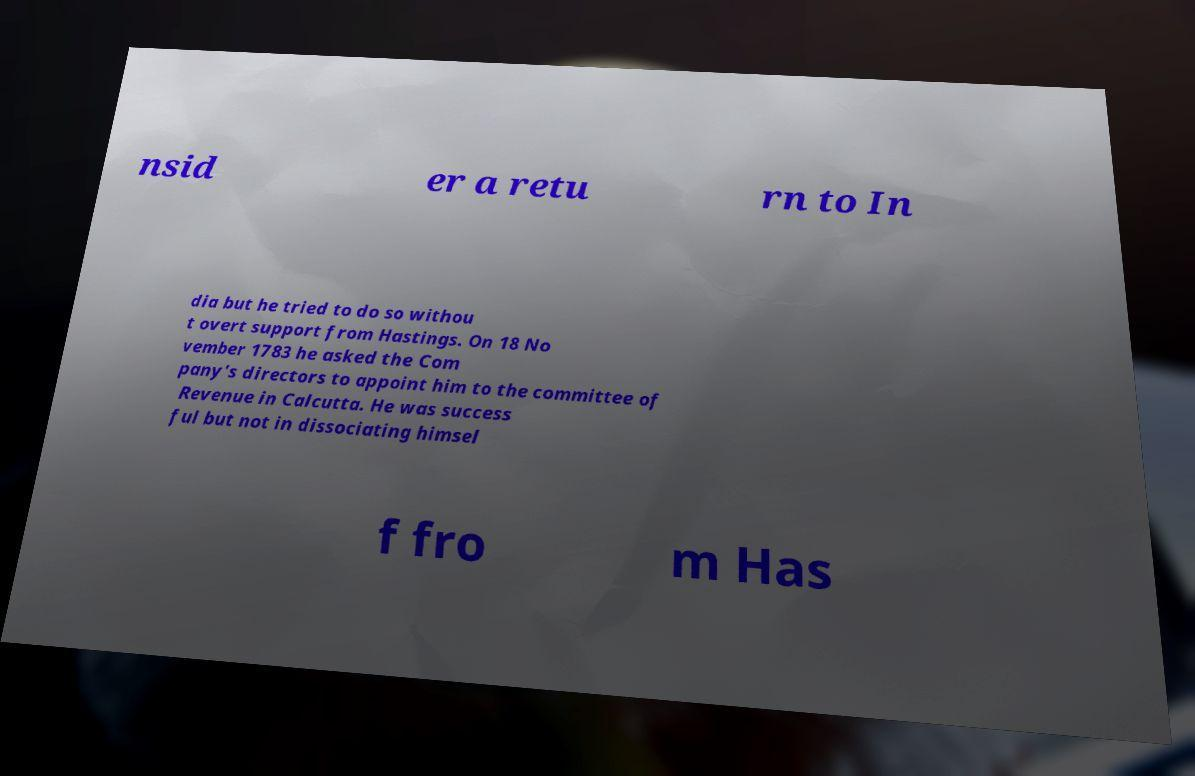I need the written content from this picture converted into text. Can you do that? nsid er a retu rn to In dia but he tried to do so withou t overt support from Hastings. On 18 No vember 1783 he asked the Com pany's directors to appoint him to the committee of Revenue in Calcutta. He was success ful but not in dissociating himsel f fro m Has 